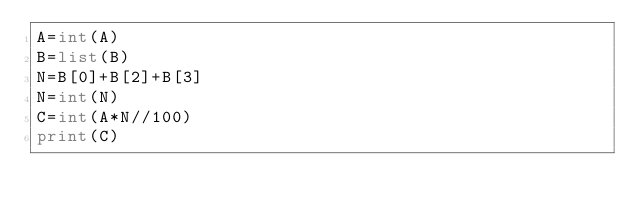Convert code to text. <code><loc_0><loc_0><loc_500><loc_500><_Python_>A=int(A)
B=list(B)
N=B[0]+B[2]+B[3]
N=int(N)
C=int(A*N//100)
print(C)</code> 